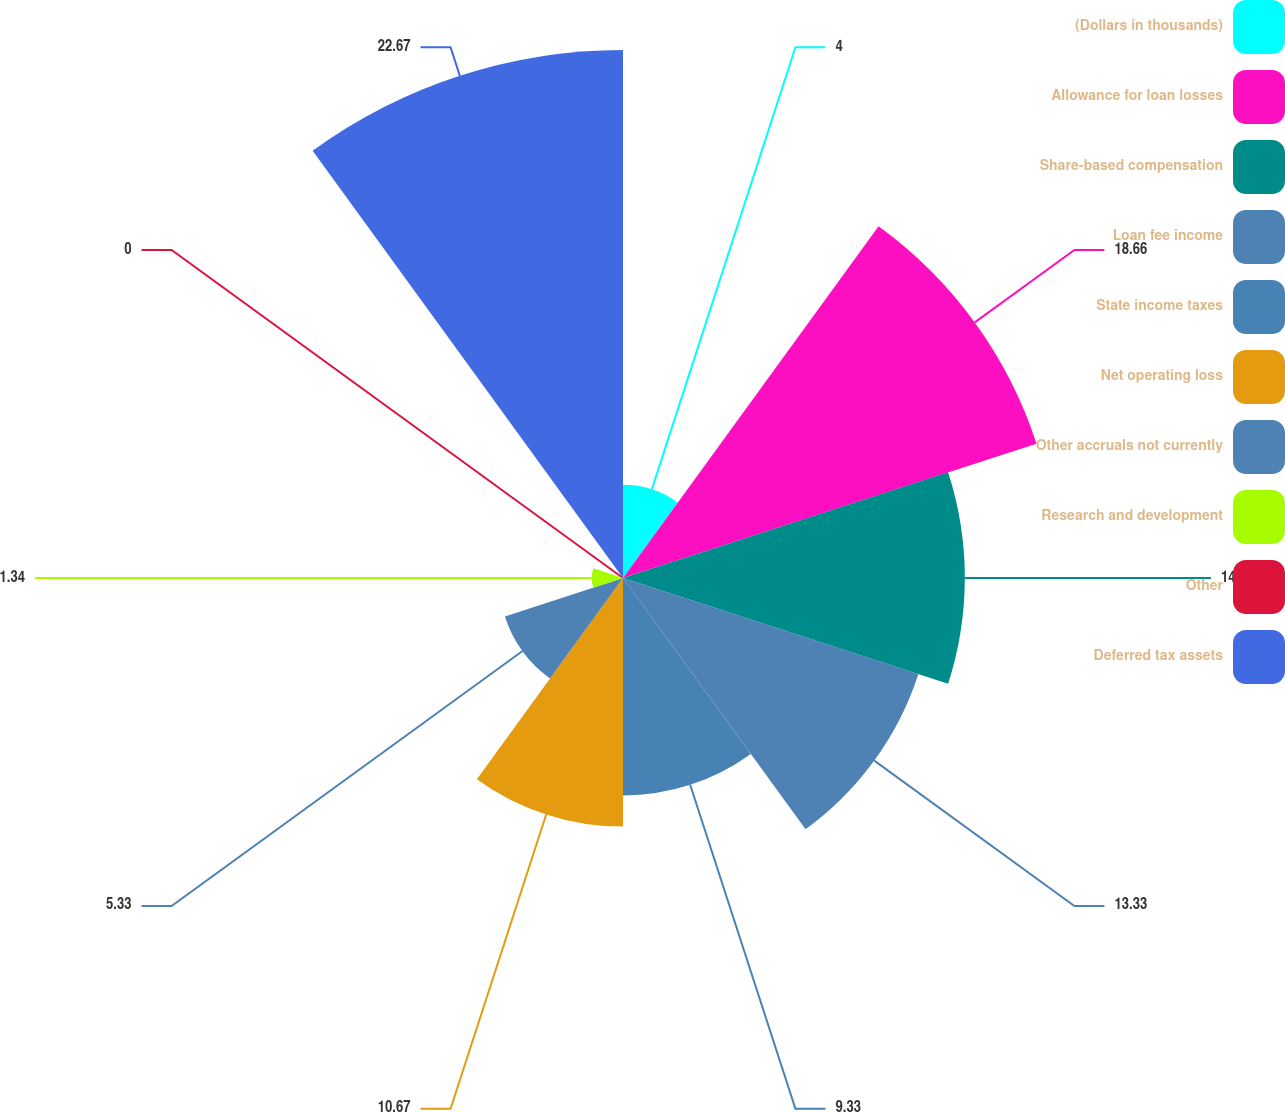Convert chart to OTSL. <chart><loc_0><loc_0><loc_500><loc_500><pie_chart><fcel>(Dollars in thousands)<fcel>Allowance for loan losses<fcel>Share-based compensation<fcel>Loan fee income<fcel>State income taxes<fcel>Net operating loss<fcel>Other accruals not currently<fcel>Research and development<fcel>Other<fcel>Deferred tax assets<nl><fcel>4.0%<fcel>18.66%<fcel>14.67%<fcel>13.33%<fcel>9.33%<fcel>10.67%<fcel>5.33%<fcel>1.34%<fcel>0.0%<fcel>22.66%<nl></chart> 